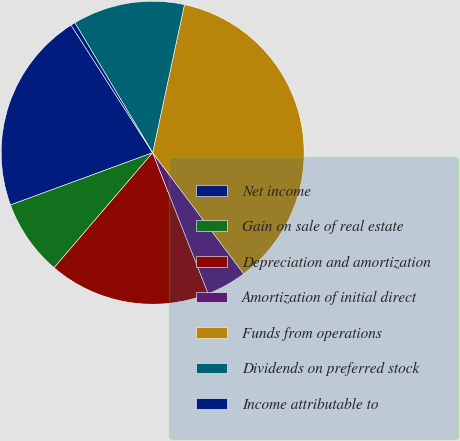Convert chart. <chart><loc_0><loc_0><loc_500><loc_500><pie_chart><fcel>Net income<fcel>Gain on sale of real estate<fcel>Depreciation and amortization<fcel>Amortization of initial direct<fcel>Funds from operations<fcel>Dividends on preferred stock<fcel>Income attributable to<nl><fcel>21.55%<fcel>8.12%<fcel>17.25%<fcel>4.29%<fcel>36.37%<fcel>11.95%<fcel>0.47%<nl></chart> 